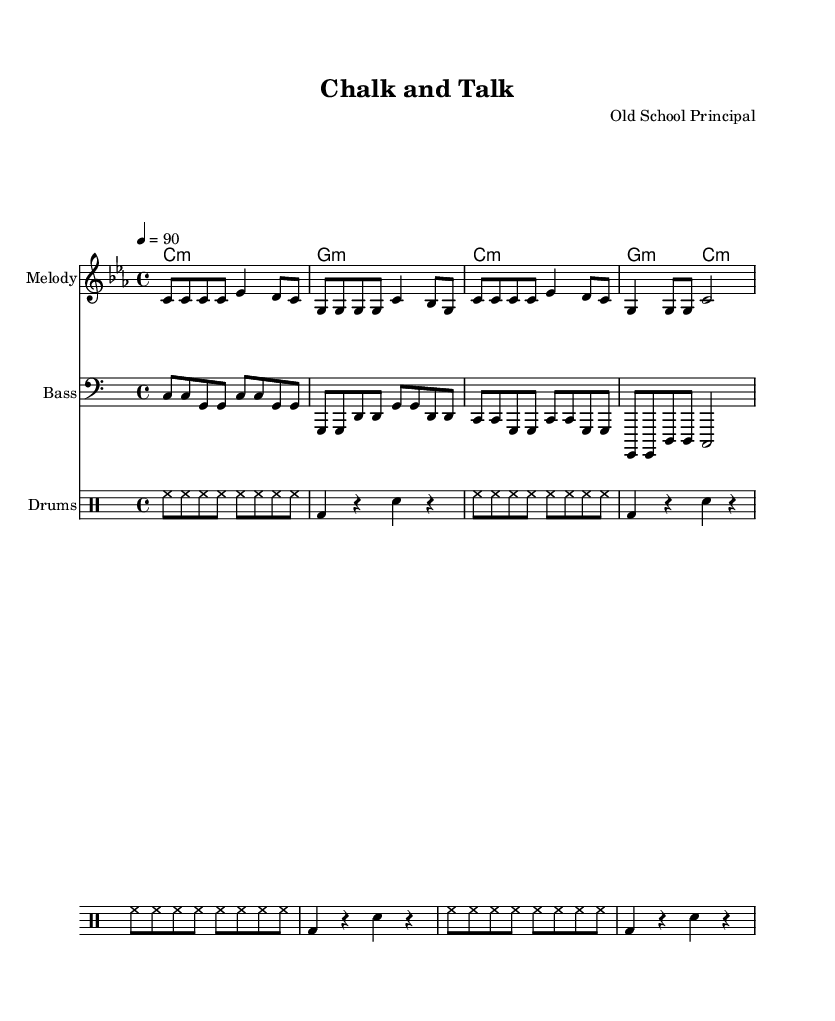What is the key signature of this music? The key signature is C minor, which contains three flats: B flat, E flat, and A flat. The key signature is indicated at the beginning of the staff where the notes are placed.
Answer: C minor What is the time signature of this piece? The time signature is found at the beginning of the score, which indicates the number of beats in each measure. Here, it is 4/4, meaning four beats per measure and a quarter note gets one beat.
Answer: 4/4 What is the tempo marking for this music? The tempo is noted at the beginning of the score, which indicates the speed of the music. In this case, it is set at 90 beats per minute. This is derived from the tempo text "4 = 90."
Answer: 90 How many measures are in the melody section? By counting the measures in the melody part, we can see that there are a total of four measures. Each measure is separated by the vertical lines, making it easy to count.
Answer: 4 What rhythmic pattern is used in the drums section? The drums feature a repeated pattern comprised of hi-hat notes (eighth notes) followed by a bass drum and snare drum in a quarter note rhythm. This pattern can be visually counted across the measures in the drumming staff.
Answer: Hi-hat and bass/snare pattern What is the overall theme of the lyrics? The lyrics promote traditional teaching methods, emphasizing discipline and classroom etiquette as fundamental to learning, evident in phrases like "Raise your hand, stand up straight." This embodies a structured educational approach.
Answer: Discipline and learning How does the bassline relate to the melody? The bassline supports the melody by emphasizing root notes that align with the chords and melody pitches. For instance, the bassline often plays the same note as the chord tones in the melody section, reinforcing harmonic structure.
Answer: Supports melody with root notes 